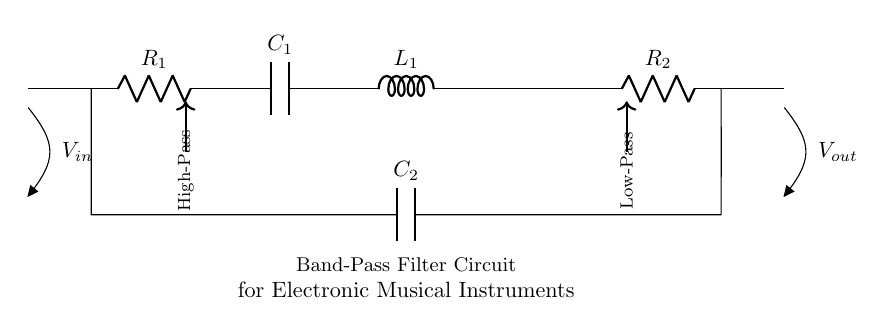What is the input voltage of the circuit? The input voltage is indicated by the label V_in, which is connected at the beginning of the circuit on the left side.
Answer: V_in What type of filter is represented by this circuit? This circuit diagram represents a band-pass filter, as indicated by the labels and the arrangement of the components that allow specific frequencies to pass while blocking others.
Answer: Band-pass filter How many resistors are in the circuit? The circuit diagram shows two resistors, labeled R_1 and R_2, positioned along the path of the circuit.
Answer: 2 What components make up the filter? The components in the filter include two resistors (R_1 and R_2), one capacitor (C_1), one inductor (L_1), and an additional capacitor (C_2) connected in parallel.
Answer: Resistors, capacitors, inductor What is the function of capacitor C_2 in this circuit? Capacitor C_2 forms a short connection between the two resistors, allowing certain frequencies to pass from R_2 to R_1, which is essential for tuning the filter to specific frequencies.
Answer: Connects resistors Which component provides low-pass filtering in the circuit? The inductor L_1 is responsible for providing low-pass filtering, filtering out frequencies above a certain cutoff by opposing changes in current.
Answer: Inductor L_1 What is the arrangement of the components for frequency response? The components are arranged such that the input signal passes through R_1 and C_1 for high-pass filtering, followed by L_1 and R_2 for low-pass filtering, resulting in a band-pass effect.
Answer: R1, C1, L1, R2 